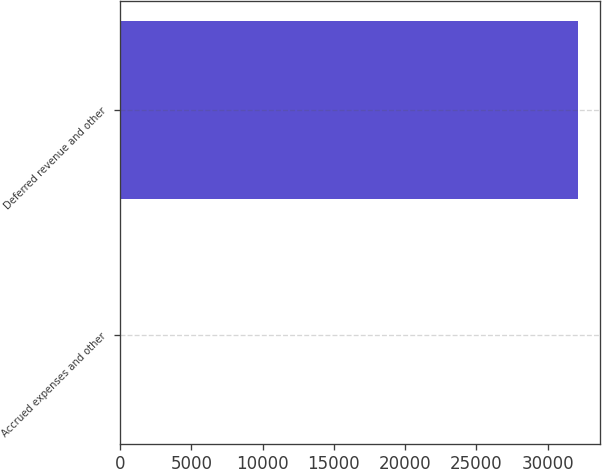<chart> <loc_0><loc_0><loc_500><loc_500><bar_chart><fcel>Accrued expenses and other<fcel>Deferred revenue and other<nl><fcel>89<fcel>32101<nl></chart> 